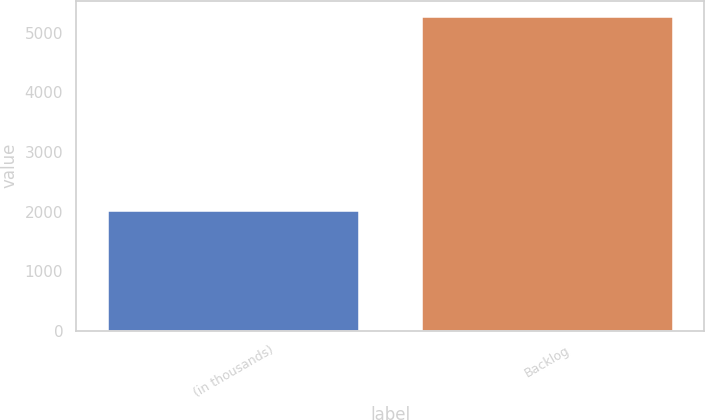Convert chart. <chart><loc_0><loc_0><loc_500><loc_500><bar_chart><fcel>(in thousands)<fcel>Backlog<nl><fcel>2008<fcel>5271<nl></chart> 